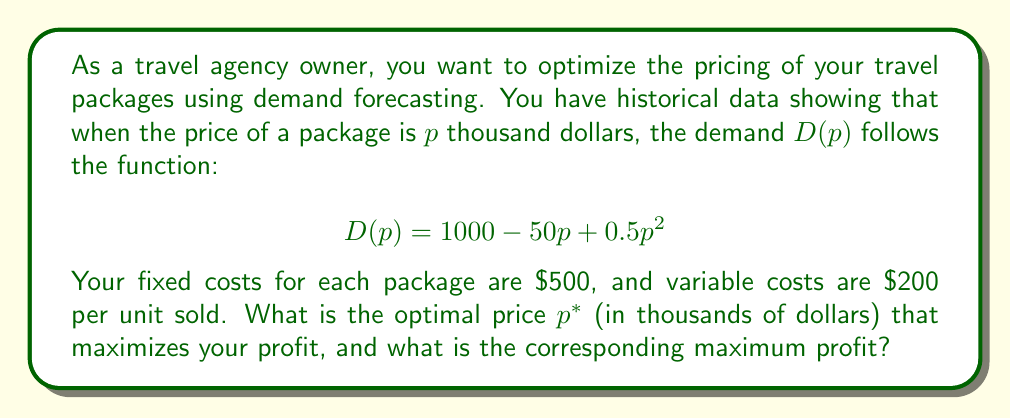What is the answer to this math problem? To solve this problem, we'll follow these steps:

1) First, let's define the profit function. The profit is the revenue minus the costs.

   Revenue = Price × Demand = $p \times D(p) = p(1000 - 50p + 0.5p^2)$
   
   Costs = Fixed costs + (Variable costs × Demand)
         = $500 + 200 \times (1000 - 50p + 0.5p^2)$

   Profit function $\Pi(p)$ = Revenue - Costs
   
   $$\Pi(p) = p(1000 - 50p + 0.5p^2) - [500 + 200(1000 - 50p + 0.5p^2)]$$

2) Expand and simplify the profit function:

   $$\Pi(p) = 1000p - 50p^2 + 0.5p^3 - 500 - 200000 + 10000p - 100p^2$$
   $$\Pi(p) = 0.5p^3 - 150p^2 + 11000p - 200500$$

3) To find the maximum profit, we need to find where the derivative of the profit function equals zero:

   $$\frac{d\Pi}{dp} = 1.5p^2 - 300p + 11000 = 0$$

4) This is a quadratic equation. We can solve it using the quadratic formula:

   $$p = \frac{-b \pm \sqrt{b^2 - 4ac}}{2a}$$

   Where $a = 1.5$, $b = -300$, and $c = 11000$

5) Solving this:

   $$p = \frac{300 \pm \sqrt{90000 - 66000}}{3} = \frac{300 \pm \sqrt{24000}}{3} = \frac{300 \pm 155}{3}$$

6) This gives us two solutions: $p_1 = 151.67$ and $p_2 = 48.33$

7) To determine which one maximizes profit, we can check the second derivative:

   $$\frac{d^2\Pi}{dp^2} = 3p - 300$$

   At $p = 151.67$, this is positive, indicating a minimum.
   At $p = 48.33$, this is negative, indicating a maximum.

8) Therefore, the optimal price $p^* = 48.33$ thousand dollars.

9) To find the maximum profit, we substitute this value back into our profit function:

   $$\Pi(48.33) = 0.5(48.33)^3 - 150(48.33)^2 + 11000(48.33) - 200500 = 261,889.06$$
Answer: The optimal price $p^*$ is $\$48,330$, and the corresponding maximum profit is $\$261,889.06$. 